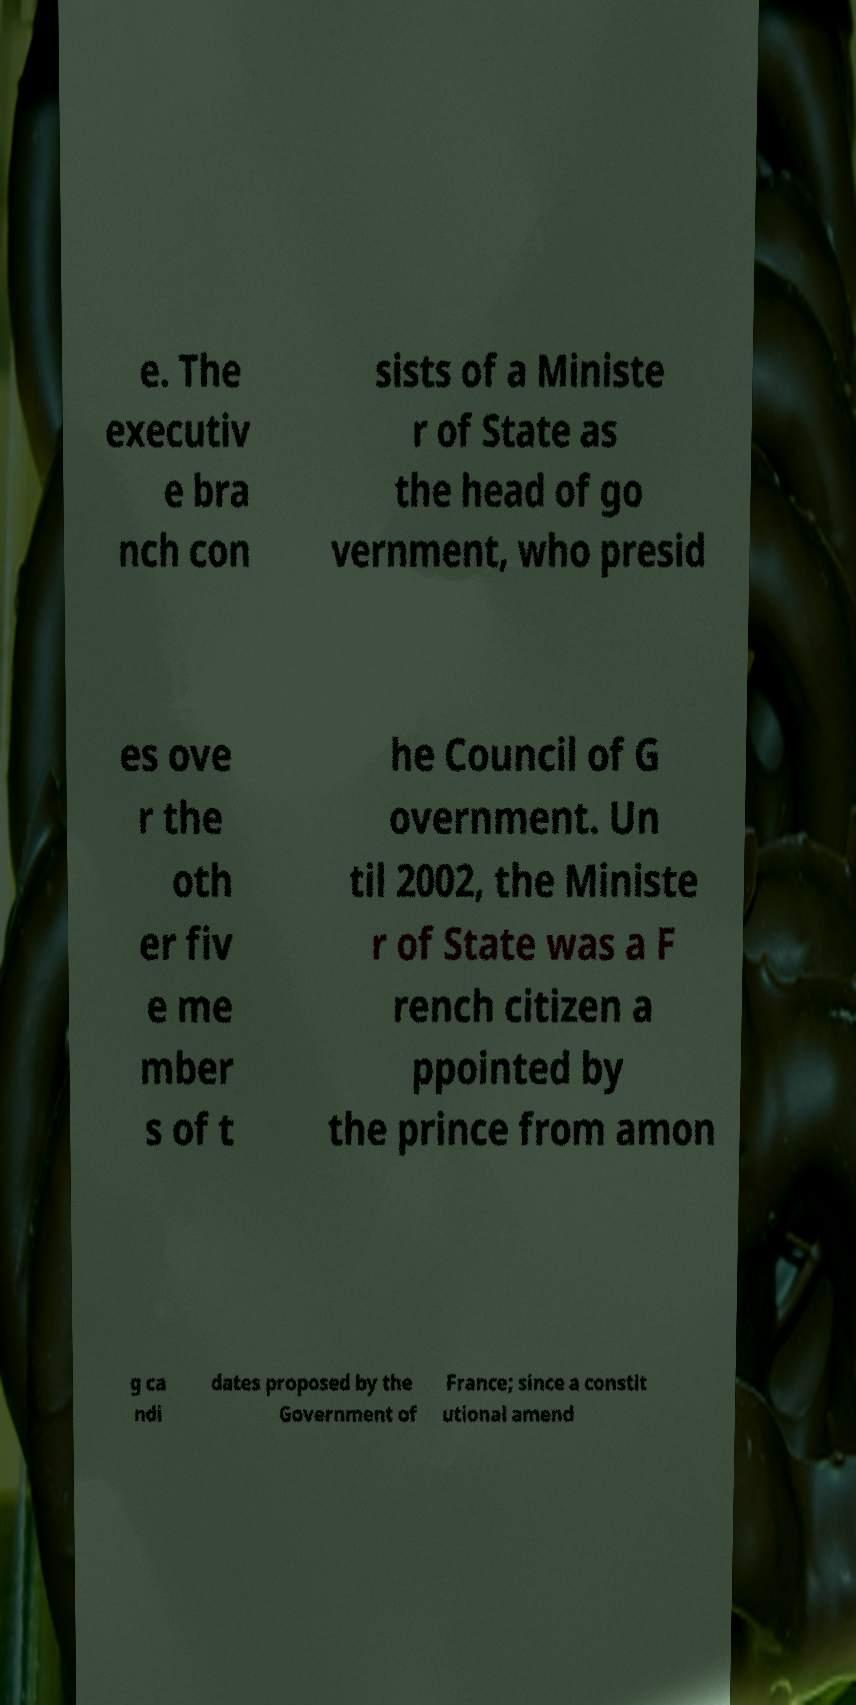Please identify and transcribe the text found in this image. e. The executiv e bra nch con sists of a Ministe r of State as the head of go vernment, who presid es ove r the oth er fiv e me mber s of t he Council of G overnment. Un til 2002, the Ministe r of State was a F rench citizen a ppointed by the prince from amon g ca ndi dates proposed by the Government of France; since a constit utional amend 